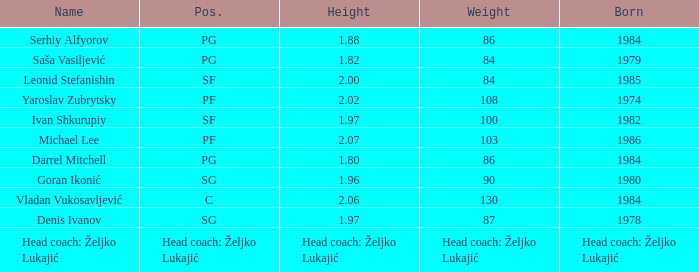What's the weight of someone born in the year 1980? 90.0. 